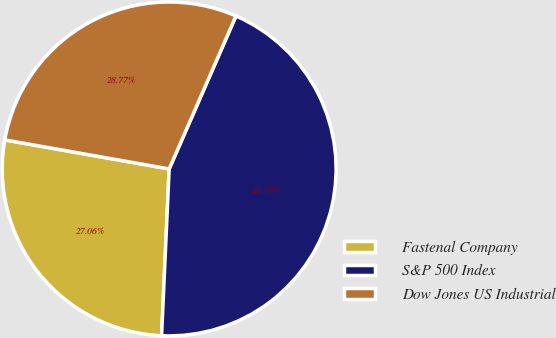<chart> <loc_0><loc_0><loc_500><loc_500><pie_chart><fcel>Fastenal Company<fcel>S&P 500 Index<fcel>Dow Jones US Industrial<nl><fcel>27.06%<fcel>44.17%<fcel>28.77%<nl></chart> 